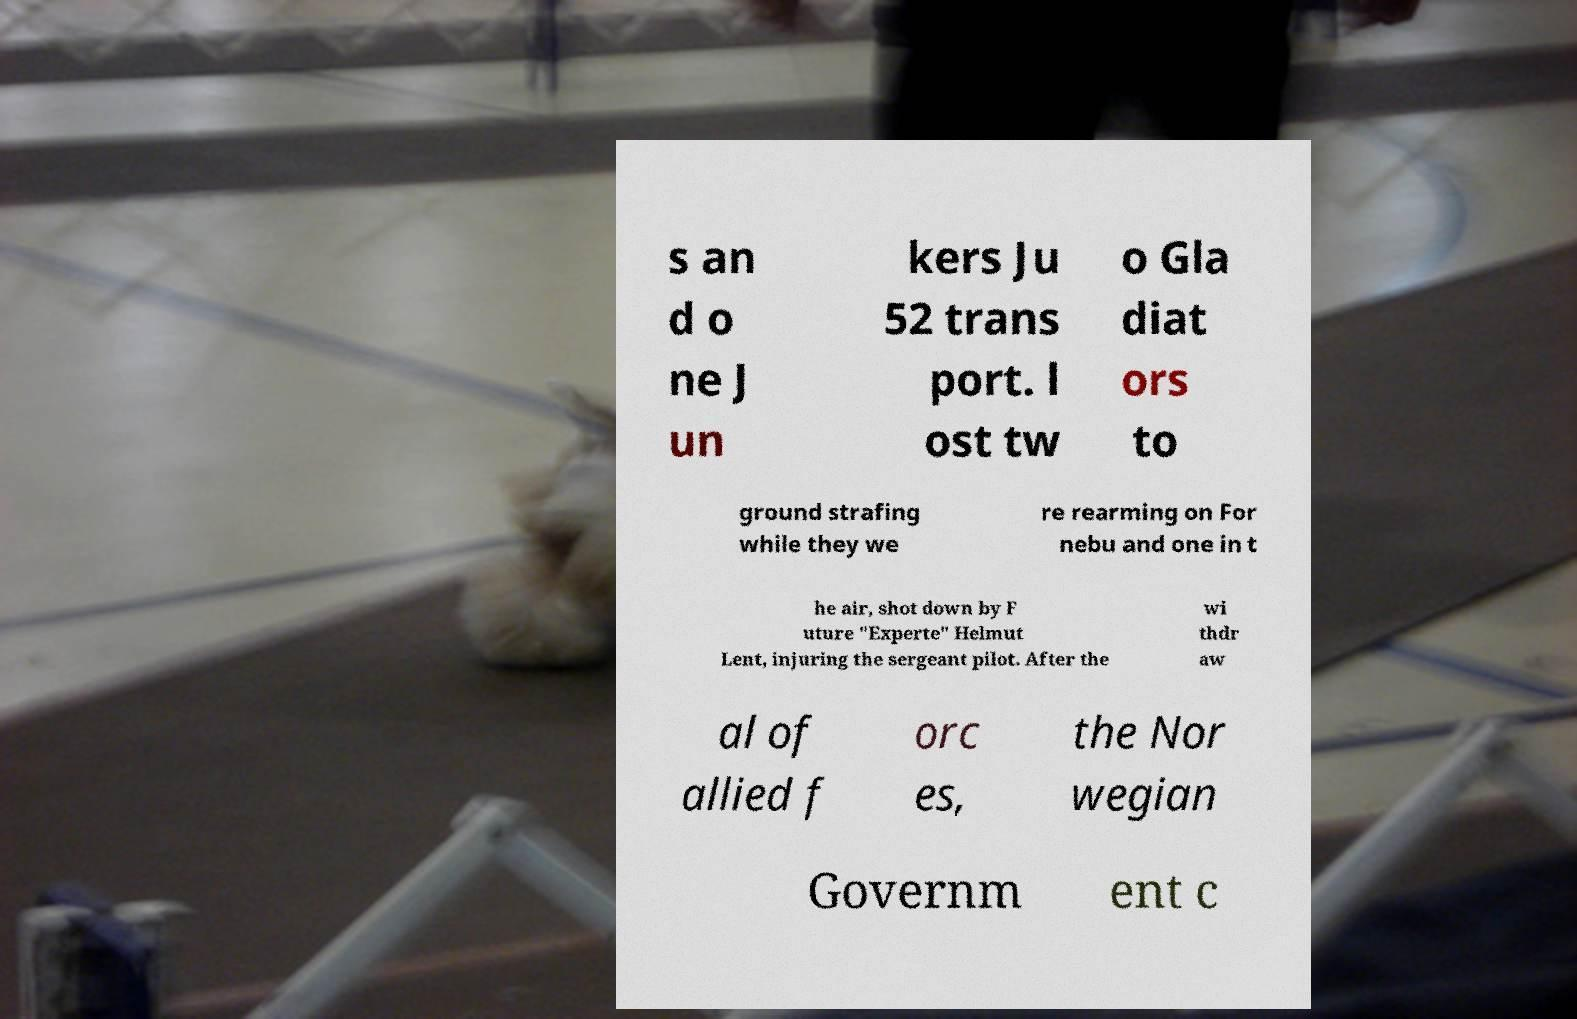Can you read and provide the text displayed in the image?This photo seems to have some interesting text. Can you extract and type it out for me? s an d o ne J un kers Ju 52 trans port. l ost tw o Gla diat ors to ground strafing while they we re rearming on For nebu and one in t he air, shot down by F uture "Experte" Helmut Lent, injuring the sergeant pilot. After the wi thdr aw al of allied f orc es, the Nor wegian Governm ent c 